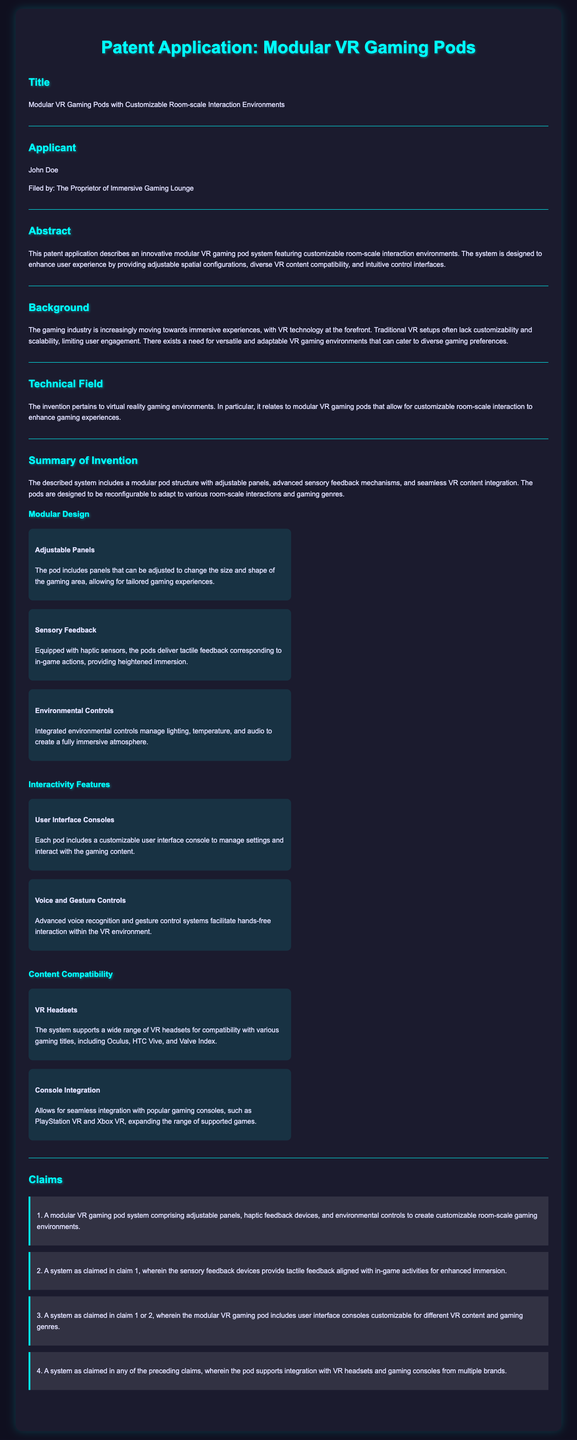What is the title of the patent application? The title is found in the "Title" section of the document.
Answer: Modular VR Gaming Pods with Customizable Room-scale Interaction Environments Who is the applicant? The applicant's name is provided in the "Applicant" section of the document.
Answer: John Doe What is the main feature that enhances immersion in the VR gaming pods? This feature is mentioned under "Sensory Feedback" in the "Summary of Invention."
Answer: Haptic sensors What type of controls are introduced for user interaction? This information is located in the "Interactivity Features" section of the document.
Answer: Voice and Gesture Controls How many claims are listed in the document? The number of claims is found in the "Claims" section where each is numbered.
Answer: Four What is the purpose of adjustable panels in the VR gaming pods? The purpose of adjustable panels is explained in the "Modular Design" section.
Answer: Change the size and shape of the gaming area What gaming consoles can the system integrate with? The specific consoles are listed under the "Console Integration" feature in the "Content Compatibility" section.
Answer: PlayStation VR and Xbox VR What is the main problem the invention aims to address? This is discussed in the "Background" section of the document.
Answer: Lack of customizability and scalability 